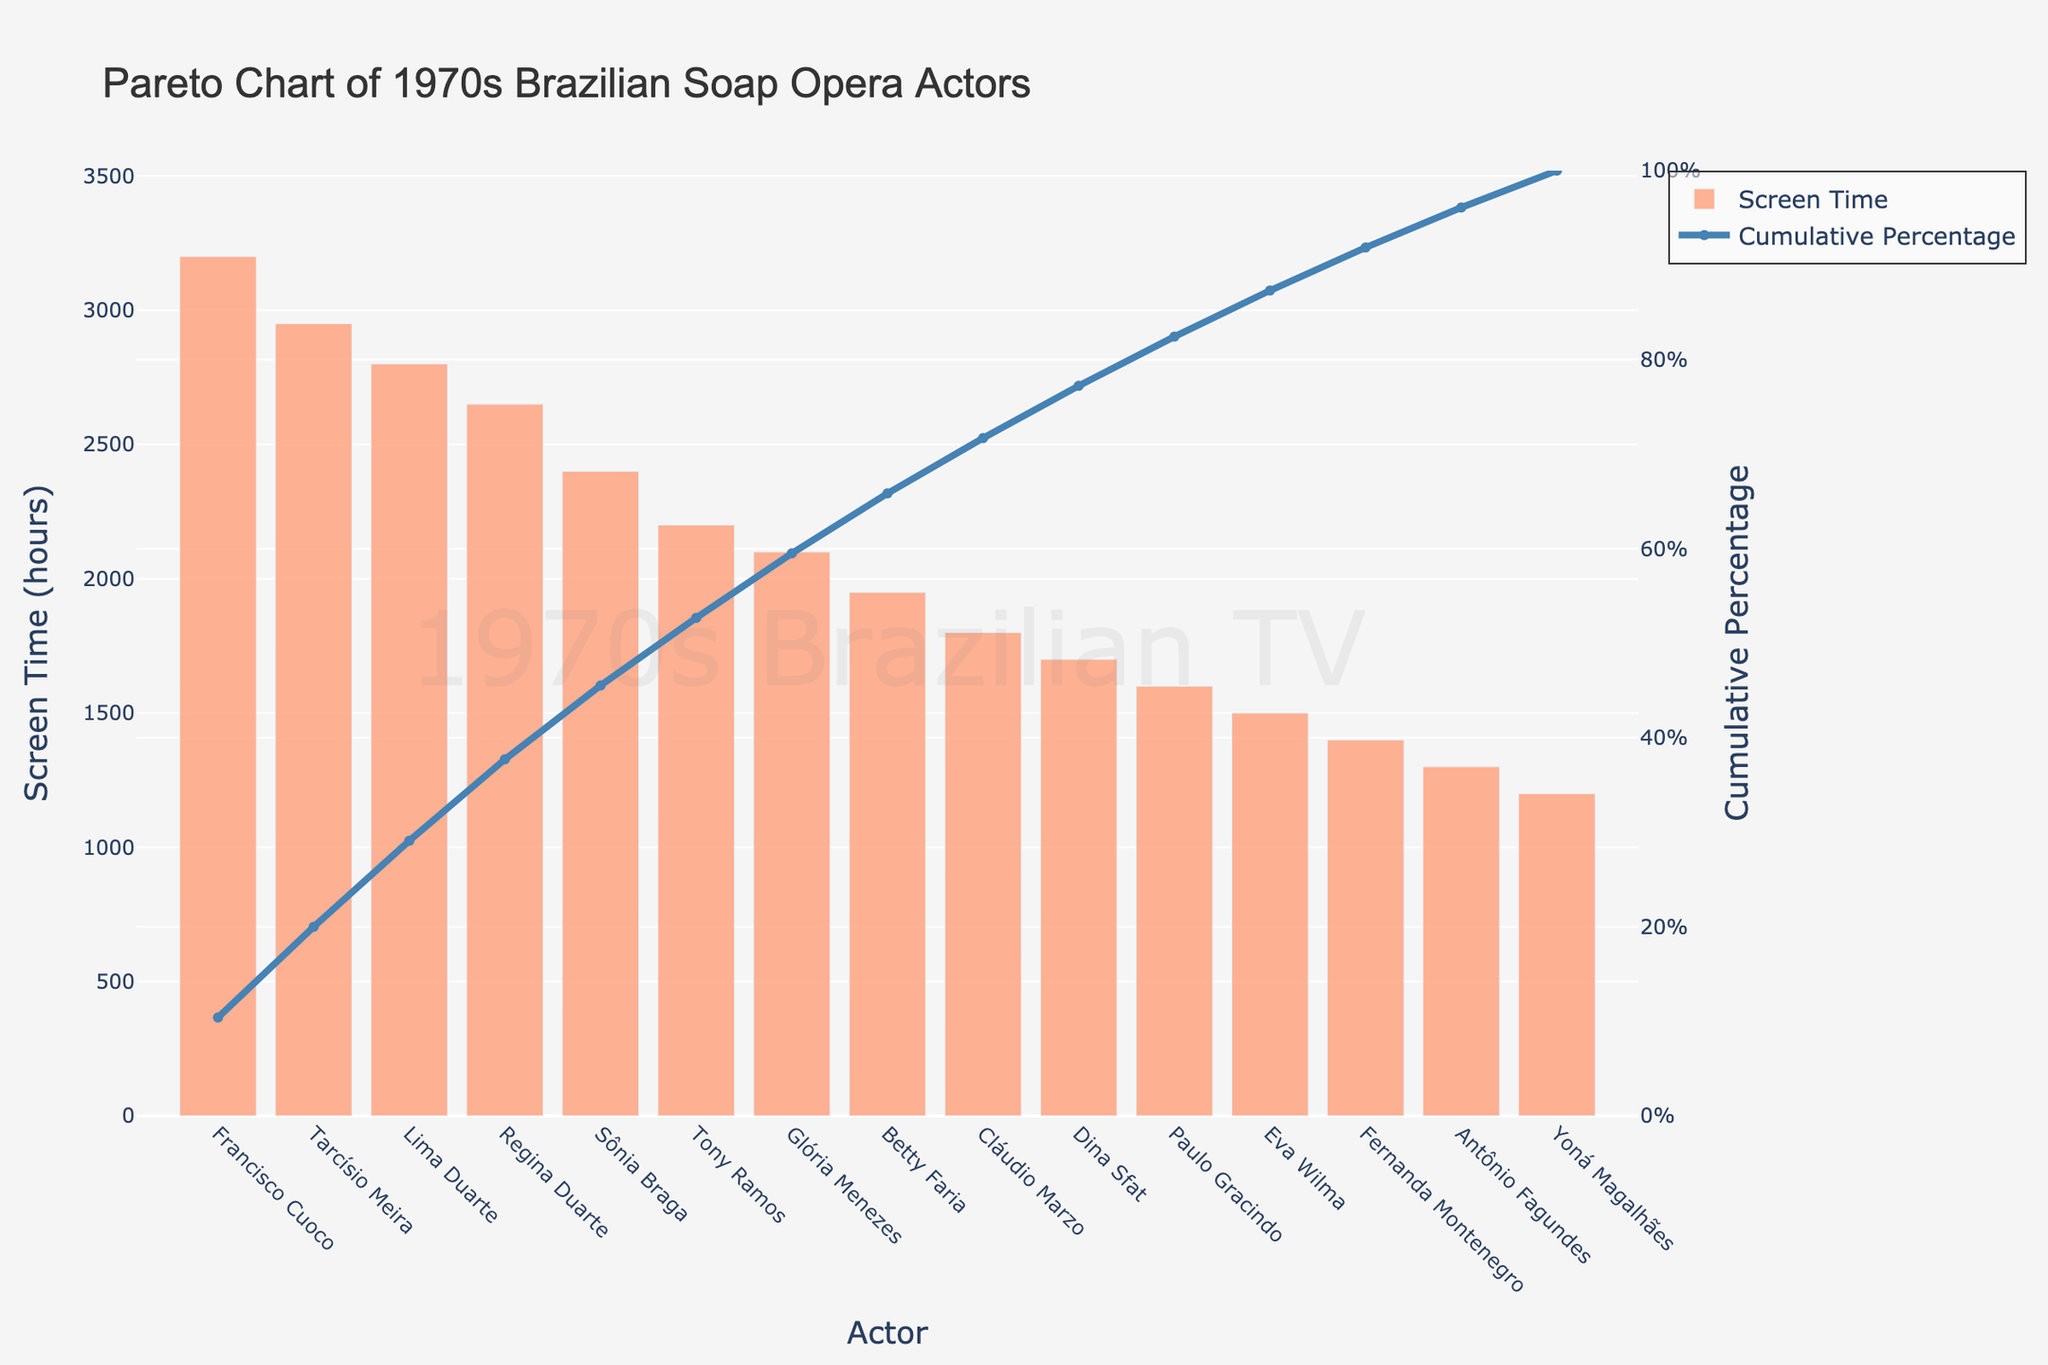What's the title of the plot? The title of the plot is located at the top and prominently displayed.
Answer: Pareto Chart of 1970s Brazilian Soap Opera Actors What is the screen time of the actor with the highest total screen time? By looking at the height of the bars, Francisco Cuoco has the highest screen time. The exact value can be found directly above his bar.
Answer: 3200 hours Which actor is associated with the cumulative percentage line that first exceeds 50%? The cumulative percentage line intersects the 50% mark between Tarcísio Meira and Lima Duarte, but it first exceeds 50% at Lima Duarte.
Answer: Lima Duarte What is the screen time difference between the actor with the highest and lowest screen time? Francisco Cuoco has the highest screen time (3200 hours) and Yoná Magalhães has the lowest (1200 hours). The difference is 3200 - 1200.
Answer: 2000 hours Among the top 5 actors by screen time, who has the lowest cumulative percentage? Among Francisco Cuoco, Tarcísio Meira, Lima Duarte, Regina Duarte, and Sônia Braga, the actor with the lowest cumulative percentage is Sônia Braga.
Answer: Sônia Braga What is the approximate screen time of Glória Menezes? The screen time is represented by the height of the ninth bar, which corresponds to Glória Menezes.
Answer: 2100 hours How many actors have a screen time that is greater than or equal to 2000 hours? By counting the bars from the left until the screen time is below 2000 hours, we find Francisco Cuoco, Tarcísio Meira, Lima Duarte, Regina Duarte, Sônia Braga, Tony Ramos, and Glória Menezes.
Answer: 7 actors What percentage of total screen time do the top two actors contribute? The cumulative percentage for the top two actors Francisco Cuoco and Tarcísio Meira can be added: (3200 + 2950) / (sum of all screen times) * 100, calculated from the cumulative percentage line.
Answer: Approximately 34.63% Who are the actors contributing to more than 75% of cumulative screen time? Observing the cumulative percentage line, the actors up until Tony Ramos contribute more than 75% of the cumulative screen time. They are Francisco Cuoco, Tarcísio Meira, Lima Duarte, Regina Duarte, Sônia Braga, and Tony Ramos.
Answer: Up to Tony Ramos 